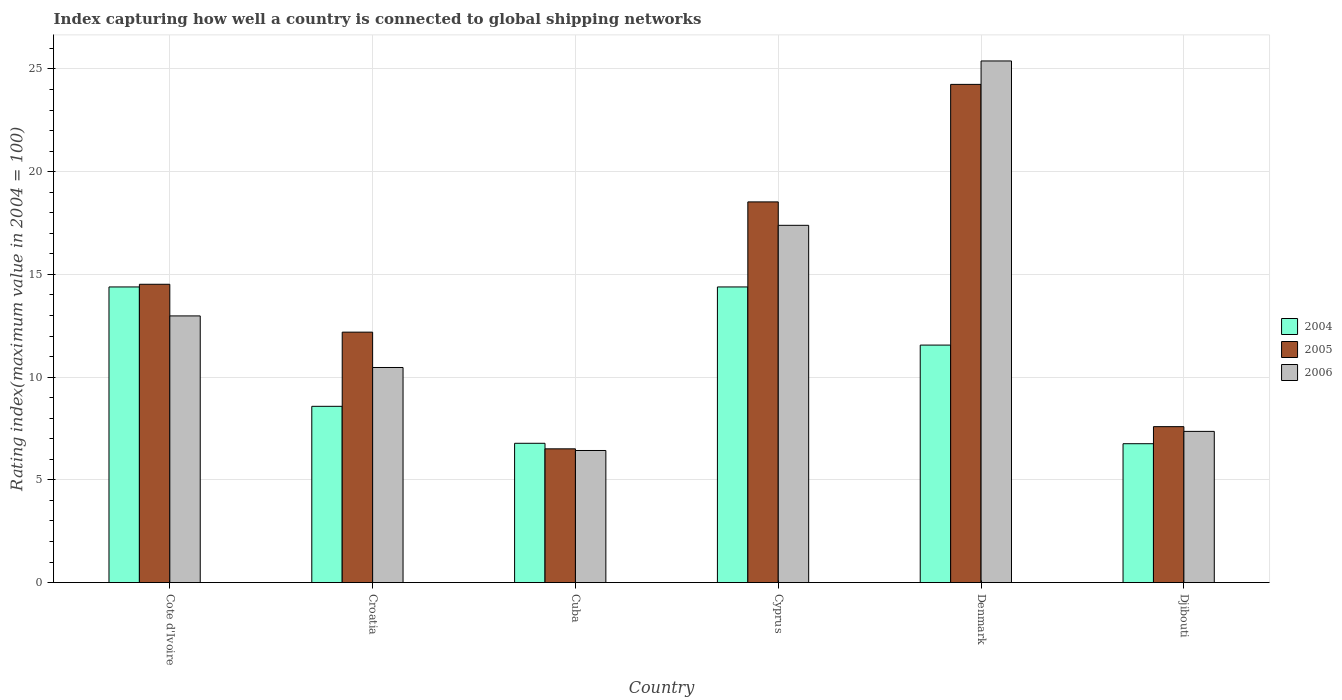How many different coloured bars are there?
Provide a succinct answer. 3. Are the number of bars per tick equal to the number of legend labels?
Provide a succinct answer. Yes. How many bars are there on the 2nd tick from the left?
Give a very brief answer. 3. What is the label of the 1st group of bars from the left?
Keep it short and to the point. Cote d'Ivoire. What is the rating index in 2004 in Denmark?
Provide a short and direct response. 11.56. Across all countries, what is the maximum rating index in 2005?
Provide a short and direct response. 24.25. Across all countries, what is the minimum rating index in 2006?
Make the answer very short. 6.43. In which country was the rating index in 2004 maximum?
Provide a succinct answer. Cote d'Ivoire. In which country was the rating index in 2004 minimum?
Offer a very short reply. Djibouti. What is the total rating index in 2006 in the graph?
Ensure brevity in your answer.  80.02. What is the difference between the rating index in 2006 in Denmark and the rating index in 2005 in Croatia?
Make the answer very short. 13.2. What is the average rating index in 2006 per country?
Your answer should be compact. 13.34. What is the difference between the rating index of/in 2005 and rating index of/in 2004 in Croatia?
Provide a short and direct response. 3.61. In how many countries, is the rating index in 2006 greater than 10?
Offer a terse response. 4. What is the ratio of the rating index in 2006 in Cote d'Ivoire to that in Djibouti?
Your answer should be compact. 1.76. Is the rating index in 2004 in Cote d'Ivoire less than that in Cyprus?
Your response must be concise. No. What is the difference between the highest and the second highest rating index in 2006?
Ensure brevity in your answer.  12.41. What is the difference between the highest and the lowest rating index in 2004?
Your answer should be very brief. 7.63. In how many countries, is the rating index in 2005 greater than the average rating index in 2005 taken over all countries?
Your response must be concise. 3. Is the sum of the rating index in 2004 in Cote d'Ivoire and Denmark greater than the maximum rating index in 2005 across all countries?
Provide a short and direct response. Yes. Is it the case that in every country, the sum of the rating index in 2005 and rating index in 2006 is greater than the rating index in 2004?
Keep it short and to the point. Yes. How many countries are there in the graph?
Give a very brief answer. 6. Does the graph contain any zero values?
Offer a terse response. No. Where does the legend appear in the graph?
Your response must be concise. Center right. How many legend labels are there?
Keep it short and to the point. 3. What is the title of the graph?
Your answer should be very brief. Index capturing how well a country is connected to global shipping networks. Does "1967" appear as one of the legend labels in the graph?
Keep it short and to the point. No. What is the label or title of the Y-axis?
Offer a terse response. Rating index(maximum value in 2004 = 100). What is the Rating index(maximum value in 2004 = 100) in 2004 in Cote d'Ivoire?
Give a very brief answer. 14.39. What is the Rating index(maximum value in 2004 = 100) in 2005 in Cote d'Ivoire?
Provide a succinct answer. 14.52. What is the Rating index(maximum value in 2004 = 100) of 2006 in Cote d'Ivoire?
Offer a very short reply. 12.98. What is the Rating index(maximum value in 2004 = 100) in 2004 in Croatia?
Your answer should be compact. 8.58. What is the Rating index(maximum value in 2004 = 100) of 2005 in Croatia?
Provide a short and direct response. 12.19. What is the Rating index(maximum value in 2004 = 100) of 2006 in Croatia?
Your response must be concise. 10.47. What is the Rating index(maximum value in 2004 = 100) of 2004 in Cuba?
Provide a short and direct response. 6.78. What is the Rating index(maximum value in 2004 = 100) in 2005 in Cuba?
Ensure brevity in your answer.  6.51. What is the Rating index(maximum value in 2004 = 100) of 2006 in Cuba?
Your answer should be compact. 6.43. What is the Rating index(maximum value in 2004 = 100) of 2004 in Cyprus?
Make the answer very short. 14.39. What is the Rating index(maximum value in 2004 = 100) of 2005 in Cyprus?
Offer a very short reply. 18.53. What is the Rating index(maximum value in 2004 = 100) in 2006 in Cyprus?
Ensure brevity in your answer.  17.39. What is the Rating index(maximum value in 2004 = 100) of 2004 in Denmark?
Give a very brief answer. 11.56. What is the Rating index(maximum value in 2004 = 100) in 2005 in Denmark?
Provide a short and direct response. 24.25. What is the Rating index(maximum value in 2004 = 100) of 2006 in Denmark?
Your answer should be very brief. 25.39. What is the Rating index(maximum value in 2004 = 100) in 2004 in Djibouti?
Ensure brevity in your answer.  6.76. What is the Rating index(maximum value in 2004 = 100) of 2005 in Djibouti?
Provide a short and direct response. 7.59. What is the Rating index(maximum value in 2004 = 100) of 2006 in Djibouti?
Offer a very short reply. 7.36. Across all countries, what is the maximum Rating index(maximum value in 2004 = 100) of 2004?
Provide a succinct answer. 14.39. Across all countries, what is the maximum Rating index(maximum value in 2004 = 100) in 2005?
Make the answer very short. 24.25. Across all countries, what is the maximum Rating index(maximum value in 2004 = 100) in 2006?
Keep it short and to the point. 25.39. Across all countries, what is the minimum Rating index(maximum value in 2004 = 100) in 2004?
Provide a succinct answer. 6.76. Across all countries, what is the minimum Rating index(maximum value in 2004 = 100) of 2005?
Provide a succinct answer. 6.51. Across all countries, what is the minimum Rating index(maximum value in 2004 = 100) in 2006?
Give a very brief answer. 6.43. What is the total Rating index(maximum value in 2004 = 100) in 2004 in the graph?
Keep it short and to the point. 62.46. What is the total Rating index(maximum value in 2004 = 100) of 2005 in the graph?
Your answer should be compact. 83.59. What is the total Rating index(maximum value in 2004 = 100) of 2006 in the graph?
Your answer should be very brief. 80.02. What is the difference between the Rating index(maximum value in 2004 = 100) of 2004 in Cote d'Ivoire and that in Croatia?
Offer a very short reply. 5.81. What is the difference between the Rating index(maximum value in 2004 = 100) in 2005 in Cote d'Ivoire and that in Croatia?
Provide a short and direct response. 2.33. What is the difference between the Rating index(maximum value in 2004 = 100) in 2006 in Cote d'Ivoire and that in Croatia?
Your response must be concise. 2.51. What is the difference between the Rating index(maximum value in 2004 = 100) of 2004 in Cote d'Ivoire and that in Cuba?
Ensure brevity in your answer.  7.61. What is the difference between the Rating index(maximum value in 2004 = 100) in 2005 in Cote d'Ivoire and that in Cuba?
Your response must be concise. 8.01. What is the difference between the Rating index(maximum value in 2004 = 100) of 2006 in Cote d'Ivoire and that in Cuba?
Provide a succinct answer. 6.55. What is the difference between the Rating index(maximum value in 2004 = 100) of 2005 in Cote d'Ivoire and that in Cyprus?
Your response must be concise. -4.01. What is the difference between the Rating index(maximum value in 2004 = 100) in 2006 in Cote d'Ivoire and that in Cyprus?
Offer a terse response. -4.41. What is the difference between the Rating index(maximum value in 2004 = 100) in 2004 in Cote d'Ivoire and that in Denmark?
Your answer should be very brief. 2.83. What is the difference between the Rating index(maximum value in 2004 = 100) in 2005 in Cote d'Ivoire and that in Denmark?
Offer a very short reply. -9.73. What is the difference between the Rating index(maximum value in 2004 = 100) in 2006 in Cote d'Ivoire and that in Denmark?
Provide a succinct answer. -12.41. What is the difference between the Rating index(maximum value in 2004 = 100) of 2004 in Cote d'Ivoire and that in Djibouti?
Keep it short and to the point. 7.63. What is the difference between the Rating index(maximum value in 2004 = 100) of 2005 in Cote d'Ivoire and that in Djibouti?
Provide a succinct answer. 6.93. What is the difference between the Rating index(maximum value in 2004 = 100) of 2006 in Cote d'Ivoire and that in Djibouti?
Your answer should be compact. 5.62. What is the difference between the Rating index(maximum value in 2004 = 100) of 2004 in Croatia and that in Cuba?
Offer a terse response. 1.8. What is the difference between the Rating index(maximum value in 2004 = 100) in 2005 in Croatia and that in Cuba?
Keep it short and to the point. 5.68. What is the difference between the Rating index(maximum value in 2004 = 100) in 2006 in Croatia and that in Cuba?
Ensure brevity in your answer.  4.04. What is the difference between the Rating index(maximum value in 2004 = 100) of 2004 in Croatia and that in Cyprus?
Make the answer very short. -5.81. What is the difference between the Rating index(maximum value in 2004 = 100) in 2005 in Croatia and that in Cyprus?
Provide a succinct answer. -6.34. What is the difference between the Rating index(maximum value in 2004 = 100) of 2006 in Croatia and that in Cyprus?
Your answer should be very brief. -6.92. What is the difference between the Rating index(maximum value in 2004 = 100) in 2004 in Croatia and that in Denmark?
Your response must be concise. -2.98. What is the difference between the Rating index(maximum value in 2004 = 100) in 2005 in Croatia and that in Denmark?
Offer a very short reply. -12.06. What is the difference between the Rating index(maximum value in 2004 = 100) in 2006 in Croatia and that in Denmark?
Ensure brevity in your answer.  -14.92. What is the difference between the Rating index(maximum value in 2004 = 100) in 2004 in Croatia and that in Djibouti?
Give a very brief answer. 1.82. What is the difference between the Rating index(maximum value in 2004 = 100) in 2006 in Croatia and that in Djibouti?
Your answer should be compact. 3.11. What is the difference between the Rating index(maximum value in 2004 = 100) of 2004 in Cuba and that in Cyprus?
Ensure brevity in your answer.  -7.61. What is the difference between the Rating index(maximum value in 2004 = 100) of 2005 in Cuba and that in Cyprus?
Offer a very short reply. -12.02. What is the difference between the Rating index(maximum value in 2004 = 100) in 2006 in Cuba and that in Cyprus?
Give a very brief answer. -10.96. What is the difference between the Rating index(maximum value in 2004 = 100) of 2004 in Cuba and that in Denmark?
Give a very brief answer. -4.78. What is the difference between the Rating index(maximum value in 2004 = 100) of 2005 in Cuba and that in Denmark?
Provide a succinct answer. -17.74. What is the difference between the Rating index(maximum value in 2004 = 100) in 2006 in Cuba and that in Denmark?
Offer a terse response. -18.96. What is the difference between the Rating index(maximum value in 2004 = 100) in 2004 in Cuba and that in Djibouti?
Make the answer very short. 0.02. What is the difference between the Rating index(maximum value in 2004 = 100) in 2005 in Cuba and that in Djibouti?
Provide a short and direct response. -1.08. What is the difference between the Rating index(maximum value in 2004 = 100) in 2006 in Cuba and that in Djibouti?
Provide a short and direct response. -0.93. What is the difference between the Rating index(maximum value in 2004 = 100) in 2004 in Cyprus and that in Denmark?
Keep it short and to the point. 2.83. What is the difference between the Rating index(maximum value in 2004 = 100) in 2005 in Cyprus and that in Denmark?
Your response must be concise. -5.72. What is the difference between the Rating index(maximum value in 2004 = 100) of 2004 in Cyprus and that in Djibouti?
Your response must be concise. 7.63. What is the difference between the Rating index(maximum value in 2004 = 100) in 2005 in Cyprus and that in Djibouti?
Make the answer very short. 10.94. What is the difference between the Rating index(maximum value in 2004 = 100) in 2006 in Cyprus and that in Djibouti?
Your response must be concise. 10.03. What is the difference between the Rating index(maximum value in 2004 = 100) of 2004 in Denmark and that in Djibouti?
Ensure brevity in your answer.  4.8. What is the difference between the Rating index(maximum value in 2004 = 100) of 2005 in Denmark and that in Djibouti?
Offer a terse response. 16.66. What is the difference between the Rating index(maximum value in 2004 = 100) in 2006 in Denmark and that in Djibouti?
Offer a very short reply. 18.03. What is the difference between the Rating index(maximum value in 2004 = 100) of 2004 in Cote d'Ivoire and the Rating index(maximum value in 2004 = 100) of 2005 in Croatia?
Your response must be concise. 2.2. What is the difference between the Rating index(maximum value in 2004 = 100) in 2004 in Cote d'Ivoire and the Rating index(maximum value in 2004 = 100) in 2006 in Croatia?
Keep it short and to the point. 3.92. What is the difference between the Rating index(maximum value in 2004 = 100) of 2005 in Cote d'Ivoire and the Rating index(maximum value in 2004 = 100) of 2006 in Croatia?
Your answer should be compact. 4.05. What is the difference between the Rating index(maximum value in 2004 = 100) in 2004 in Cote d'Ivoire and the Rating index(maximum value in 2004 = 100) in 2005 in Cuba?
Make the answer very short. 7.88. What is the difference between the Rating index(maximum value in 2004 = 100) in 2004 in Cote d'Ivoire and the Rating index(maximum value in 2004 = 100) in 2006 in Cuba?
Your answer should be very brief. 7.96. What is the difference between the Rating index(maximum value in 2004 = 100) of 2005 in Cote d'Ivoire and the Rating index(maximum value in 2004 = 100) of 2006 in Cuba?
Make the answer very short. 8.09. What is the difference between the Rating index(maximum value in 2004 = 100) of 2004 in Cote d'Ivoire and the Rating index(maximum value in 2004 = 100) of 2005 in Cyprus?
Ensure brevity in your answer.  -4.14. What is the difference between the Rating index(maximum value in 2004 = 100) in 2005 in Cote d'Ivoire and the Rating index(maximum value in 2004 = 100) in 2006 in Cyprus?
Provide a succinct answer. -2.87. What is the difference between the Rating index(maximum value in 2004 = 100) of 2004 in Cote d'Ivoire and the Rating index(maximum value in 2004 = 100) of 2005 in Denmark?
Provide a succinct answer. -9.86. What is the difference between the Rating index(maximum value in 2004 = 100) of 2004 in Cote d'Ivoire and the Rating index(maximum value in 2004 = 100) of 2006 in Denmark?
Offer a very short reply. -11. What is the difference between the Rating index(maximum value in 2004 = 100) in 2005 in Cote d'Ivoire and the Rating index(maximum value in 2004 = 100) in 2006 in Denmark?
Ensure brevity in your answer.  -10.87. What is the difference between the Rating index(maximum value in 2004 = 100) of 2004 in Cote d'Ivoire and the Rating index(maximum value in 2004 = 100) of 2006 in Djibouti?
Offer a terse response. 7.03. What is the difference between the Rating index(maximum value in 2004 = 100) of 2005 in Cote d'Ivoire and the Rating index(maximum value in 2004 = 100) of 2006 in Djibouti?
Your response must be concise. 7.16. What is the difference between the Rating index(maximum value in 2004 = 100) of 2004 in Croatia and the Rating index(maximum value in 2004 = 100) of 2005 in Cuba?
Provide a succinct answer. 2.07. What is the difference between the Rating index(maximum value in 2004 = 100) in 2004 in Croatia and the Rating index(maximum value in 2004 = 100) in 2006 in Cuba?
Keep it short and to the point. 2.15. What is the difference between the Rating index(maximum value in 2004 = 100) in 2005 in Croatia and the Rating index(maximum value in 2004 = 100) in 2006 in Cuba?
Keep it short and to the point. 5.76. What is the difference between the Rating index(maximum value in 2004 = 100) of 2004 in Croatia and the Rating index(maximum value in 2004 = 100) of 2005 in Cyprus?
Make the answer very short. -9.95. What is the difference between the Rating index(maximum value in 2004 = 100) in 2004 in Croatia and the Rating index(maximum value in 2004 = 100) in 2006 in Cyprus?
Give a very brief answer. -8.81. What is the difference between the Rating index(maximum value in 2004 = 100) in 2005 in Croatia and the Rating index(maximum value in 2004 = 100) in 2006 in Cyprus?
Your answer should be compact. -5.2. What is the difference between the Rating index(maximum value in 2004 = 100) in 2004 in Croatia and the Rating index(maximum value in 2004 = 100) in 2005 in Denmark?
Your answer should be very brief. -15.67. What is the difference between the Rating index(maximum value in 2004 = 100) in 2004 in Croatia and the Rating index(maximum value in 2004 = 100) in 2006 in Denmark?
Provide a succinct answer. -16.81. What is the difference between the Rating index(maximum value in 2004 = 100) in 2005 in Croatia and the Rating index(maximum value in 2004 = 100) in 2006 in Denmark?
Ensure brevity in your answer.  -13.2. What is the difference between the Rating index(maximum value in 2004 = 100) in 2004 in Croatia and the Rating index(maximum value in 2004 = 100) in 2005 in Djibouti?
Keep it short and to the point. 0.99. What is the difference between the Rating index(maximum value in 2004 = 100) of 2004 in Croatia and the Rating index(maximum value in 2004 = 100) of 2006 in Djibouti?
Provide a short and direct response. 1.22. What is the difference between the Rating index(maximum value in 2004 = 100) of 2005 in Croatia and the Rating index(maximum value in 2004 = 100) of 2006 in Djibouti?
Provide a short and direct response. 4.83. What is the difference between the Rating index(maximum value in 2004 = 100) in 2004 in Cuba and the Rating index(maximum value in 2004 = 100) in 2005 in Cyprus?
Offer a very short reply. -11.75. What is the difference between the Rating index(maximum value in 2004 = 100) in 2004 in Cuba and the Rating index(maximum value in 2004 = 100) in 2006 in Cyprus?
Offer a very short reply. -10.61. What is the difference between the Rating index(maximum value in 2004 = 100) of 2005 in Cuba and the Rating index(maximum value in 2004 = 100) of 2006 in Cyprus?
Ensure brevity in your answer.  -10.88. What is the difference between the Rating index(maximum value in 2004 = 100) in 2004 in Cuba and the Rating index(maximum value in 2004 = 100) in 2005 in Denmark?
Your answer should be very brief. -17.47. What is the difference between the Rating index(maximum value in 2004 = 100) in 2004 in Cuba and the Rating index(maximum value in 2004 = 100) in 2006 in Denmark?
Give a very brief answer. -18.61. What is the difference between the Rating index(maximum value in 2004 = 100) of 2005 in Cuba and the Rating index(maximum value in 2004 = 100) of 2006 in Denmark?
Provide a succinct answer. -18.88. What is the difference between the Rating index(maximum value in 2004 = 100) in 2004 in Cuba and the Rating index(maximum value in 2004 = 100) in 2005 in Djibouti?
Offer a terse response. -0.81. What is the difference between the Rating index(maximum value in 2004 = 100) of 2004 in Cuba and the Rating index(maximum value in 2004 = 100) of 2006 in Djibouti?
Ensure brevity in your answer.  -0.58. What is the difference between the Rating index(maximum value in 2004 = 100) in 2005 in Cuba and the Rating index(maximum value in 2004 = 100) in 2006 in Djibouti?
Offer a terse response. -0.85. What is the difference between the Rating index(maximum value in 2004 = 100) of 2004 in Cyprus and the Rating index(maximum value in 2004 = 100) of 2005 in Denmark?
Provide a short and direct response. -9.86. What is the difference between the Rating index(maximum value in 2004 = 100) in 2004 in Cyprus and the Rating index(maximum value in 2004 = 100) in 2006 in Denmark?
Provide a succinct answer. -11. What is the difference between the Rating index(maximum value in 2004 = 100) in 2005 in Cyprus and the Rating index(maximum value in 2004 = 100) in 2006 in Denmark?
Ensure brevity in your answer.  -6.86. What is the difference between the Rating index(maximum value in 2004 = 100) in 2004 in Cyprus and the Rating index(maximum value in 2004 = 100) in 2005 in Djibouti?
Your response must be concise. 6.8. What is the difference between the Rating index(maximum value in 2004 = 100) of 2004 in Cyprus and the Rating index(maximum value in 2004 = 100) of 2006 in Djibouti?
Your response must be concise. 7.03. What is the difference between the Rating index(maximum value in 2004 = 100) in 2005 in Cyprus and the Rating index(maximum value in 2004 = 100) in 2006 in Djibouti?
Your answer should be very brief. 11.17. What is the difference between the Rating index(maximum value in 2004 = 100) in 2004 in Denmark and the Rating index(maximum value in 2004 = 100) in 2005 in Djibouti?
Provide a short and direct response. 3.97. What is the difference between the Rating index(maximum value in 2004 = 100) of 2004 in Denmark and the Rating index(maximum value in 2004 = 100) of 2006 in Djibouti?
Provide a succinct answer. 4.2. What is the difference between the Rating index(maximum value in 2004 = 100) of 2005 in Denmark and the Rating index(maximum value in 2004 = 100) of 2006 in Djibouti?
Make the answer very short. 16.89. What is the average Rating index(maximum value in 2004 = 100) of 2004 per country?
Make the answer very short. 10.41. What is the average Rating index(maximum value in 2004 = 100) of 2005 per country?
Provide a short and direct response. 13.93. What is the average Rating index(maximum value in 2004 = 100) of 2006 per country?
Provide a succinct answer. 13.34. What is the difference between the Rating index(maximum value in 2004 = 100) in 2004 and Rating index(maximum value in 2004 = 100) in 2005 in Cote d'Ivoire?
Your answer should be very brief. -0.13. What is the difference between the Rating index(maximum value in 2004 = 100) of 2004 and Rating index(maximum value in 2004 = 100) of 2006 in Cote d'Ivoire?
Ensure brevity in your answer.  1.41. What is the difference between the Rating index(maximum value in 2004 = 100) in 2005 and Rating index(maximum value in 2004 = 100) in 2006 in Cote d'Ivoire?
Provide a short and direct response. 1.54. What is the difference between the Rating index(maximum value in 2004 = 100) of 2004 and Rating index(maximum value in 2004 = 100) of 2005 in Croatia?
Your response must be concise. -3.61. What is the difference between the Rating index(maximum value in 2004 = 100) in 2004 and Rating index(maximum value in 2004 = 100) in 2006 in Croatia?
Make the answer very short. -1.89. What is the difference between the Rating index(maximum value in 2004 = 100) in 2005 and Rating index(maximum value in 2004 = 100) in 2006 in Croatia?
Provide a short and direct response. 1.72. What is the difference between the Rating index(maximum value in 2004 = 100) in 2004 and Rating index(maximum value in 2004 = 100) in 2005 in Cuba?
Give a very brief answer. 0.27. What is the difference between the Rating index(maximum value in 2004 = 100) in 2004 and Rating index(maximum value in 2004 = 100) in 2006 in Cuba?
Provide a succinct answer. 0.35. What is the difference between the Rating index(maximum value in 2004 = 100) of 2004 and Rating index(maximum value in 2004 = 100) of 2005 in Cyprus?
Your answer should be very brief. -4.14. What is the difference between the Rating index(maximum value in 2004 = 100) in 2004 and Rating index(maximum value in 2004 = 100) in 2006 in Cyprus?
Your response must be concise. -3. What is the difference between the Rating index(maximum value in 2004 = 100) of 2005 and Rating index(maximum value in 2004 = 100) of 2006 in Cyprus?
Your answer should be very brief. 1.14. What is the difference between the Rating index(maximum value in 2004 = 100) in 2004 and Rating index(maximum value in 2004 = 100) in 2005 in Denmark?
Make the answer very short. -12.69. What is the difference between the Rating index(maximum value in 2004 = 100) of 2004 and Rating index(maximum value in 2004 = 100) of 2006 in Denmark?
Make the answer very short. -13.83. What is the difference between the Rating index(maximum value in 2004 = 100) in 2005 and Rating index(maximum value in 2004 = 100) in 2006 in Denmark?
Your answer should be very brief. -1.14. What is the difference between the Rating index(maximum value in 2004 = 100) in 2004 and Rating index(maximum value in 2004 = 100) in 2005 in Djibouti?
Ensure brevity in your answer.  -0.83. What is the difference between the Rating index(maximum value in 2004 = 100) of 2005 and Rating index(maximum value in 2004 = 100) of 2006 in Djibouti?
Make the answer very short. 0.23. What is the ratio of the Rating index(maximum value in 2004 = 100) of 2004 in Cote d'Ivoire to that in Croatia?
Keep it short and to the point. 1.68. What is the ratio of the Rating index(maximum value in 2004 = 100) of 2005 in Cote d'Ivoire to that in Croatia?
Keep it short and to the point. 1.19. What is the ratio of the Rating index(maximum value in 2004 = 100) in 2006 in Cote d'Ivoire to that in Croatia?
Give a very brief answer. 1.24. What is the ratio of the Rating index(maximum value in 2004 = 100) of 2004 in Cote d'Ivoire to that in Cuba?
Give a very brief answer. 2.12. What is the ratio of the Rating index(maximum value in 2004 = 100) in 2005 in Cote d'Ivoire to that in Cuba?
Your answer should be compact. 2.23. What is the ratio of the Rating index(maximum value in 2004 = 100) in 2006 in Cote d'Ivoire to that in Cuba?
Provide a succinct answer. 2.02. What is the ratio of the Rating index(maximum value in 2004 = 100) of 2004 in Cote d'Ivoire to that in Cyprus?
Keep it short and to the point. 1. What is the ratio of the Rating index(maximum value in 2004 = 100) of 2005 in Cote d'Ivoire to that in Cyprus?
Your response must be concise. 0.78. What is the ratio of the Rating index(maximum value in 2004 = 100) of 2006 in Cote d'Ivoire to that in Cyprus?
Your answer should be very brief. 0.75. What is the ratio of the Rating index(maximum value in 2004 = 100) of 2004 in Cote d'Ivoire to that in Denmark?
Make the answer very short. 1.24. What is the ratio of the Rating index(maximum value in 2004 = 100) of 2005 in Cote d'Ivoire to that in Denmark?
Keep it short and to the point. 0.6. What is the ratio of the Rating index(maximum value in 2004 = 100) of 2006 in Cote d'Ivoire to that in Denmark?
Make the answer very short. 0.51. What is the ratio of the Rating index(maximum value in 2004 = 100) in 2004 in Cote d'Ivoire to that in Djibouti?
Offer a very short reply. 2.13. What is the ratio of the Rating index(maximum value in 2004 = 100) in 2005 in Cote d'Ivoire to that in Djibouti?
Your answer should be compact. 1.91. What is the ratio of the Rating index(maximum value in 2004 = 100) of 2006 in Cote d'Ivoire to that in Djibouti?
Provide a short and direct response. 1.76. What is the ratio of the Rating index(maximum value in 2004 = 100) of 2004 in Croatia to that in Cuba?
Offer a terse response. 1.27. What is the ratio of the Rating index(maximum value in 2004 = 100) of 2005 in Croatia to that in Cuba?
Ensure brevity in your answer.  1.87. What is the ratio of the Rating index(maximum value in 2004 = 100) of 2006 in Croatia to that in Cuba?
Give a very brief answer. 1.63. What is the ratio of the Rating index(maximum value in 2004 = 100) of 2004 in Croatia to that in Cyprus?
Your answer should be very brief. 0.6. What is the ratio of the Rating index(maximum value in 2004 = 100) of 2005 in Croatia to that in Cyprus?
Provide a short and direct response. 0.66. What is the ratio of the Rating index(maximum value in 2004 = 100) of 2006 in Croatia to that in Cyprus?
Offer a very short reply. 0.6. What is the ratio of the Rating index(maximum value in 2004 = 100) of 2004 in Croatia to that in Denmark?
Provide a short and direct response. 0.74. What is the ratio of the Rating index(maximum value in 2004 = 100) in 2005 in Croatia to that in Denmark?
Ensure brevity in your answer.  0.5. What is the ratio of the Rating index(maximum value in 2004 = 100) of 2006 in Croatia to that in Denmark?
Your answer should be compact. 0.41. What is the ratio of the Rating index(maximum value in 2004 = 100) in 2004 in Croatia to that in Djibouti?
Your response must be concise. 1.27. What is the ratio of the Rating index(maximum value in 2004 = 100) of 2005 in Croatia to that in Djibouti?
Ensure brevity in your answer.  1.61. What is the ratio of the Rating index(maximum value in 2004 = 100) in 2006 in Croatia to that in Djibouti?
Offer a very short reply. 1.42. What is the ratio of the Rating index(maximum value in 2004 = 100) of 2004 in Cuba to that in Cyprus?
Ensure brevity in your answer.  0.47. What is the ratio of the Rating index(maximum value in 2004 = 100) of 2005 in Cuba to that in Cyprus?
Make the answer very short. 0.35. What is the ratio of the Rating index(maximum value in 2004 = 100) of 2006 in Cuba to that in Cyprus?
Provide a succinct answer. 0.37. What is the ratio of the Rating index(maximum value in 2004 = 100) in 2004 in Cuba to that in Denmark?
Give a very brief answer. 0.59. What is the ratio of the Rating index(maximum value in 2004 = 100) in 2005 in Cuba to that in Denmark?
Your answer should be compact. 0.27. What is the ratio of the Rating index(maximum value in 2004 = 100) in 2006 in Cuba to that in Denmark?
Offer a very short reply. 0.25. What is the ratio of the Rating index(maximum value in 2004 = 100) of 2005 in Cuba to that in Djibouti?
Ensure brevity in your answer.  0.86. What is the ratio of the Rating index(maximum value in 2004 = 100) in 2006 in Cuba to that in Djibouti?
Make the answer very short. 0.87. What is the ratio of the Rating index(maximum value in 2004 = 100) of 2004 in Cyprus to that in Denmark?
Your answer should be compact. 1.24. What is the ratio of the Rating index(maximum value in 2004 = 100) of 2005 in Cyprus to that in Denmark?
Give a very brief answer. 0.76. What is the ratio of the Rating index(maximum value in 2004 = 100) of 2006 in Cyprus to that in Denmark?
Your answer should be compact. 0.68. What is the ratio of the Rating index(maximum value in 2004 = 100) of 2004 in Cyprus to that in Djibouti?
Offer a terse response. 2.13. What is the ratio of the Rating index(maximum value in 2004 = 100) of 2005 in Cyprus to that in Djibouti?
Your answer should be compact. 2.44. What is the ratio of the Rating index(maximum value in 2004 = 100) in 2006 in Cyprus to that in Djibouti?
Provide a short and direct response. 2.36. What is the ratio of the Rating index(maximum value in 2004 = 100) in 2004 in Denmark to that in Djibouti?
Provide a short and direct response. 1.71. What is the ratio of the Rating index(maximum value in 2004 = 100) of 2005 in Denmark to that in Djibouti?
Make the answer very short. 3.19. What is the ratio of the Rating index(maximum value in 2004 = 100) in 2006 in Denmark to that in Djibouti?
Your answer should be compact. 3.45. What is the difference between the highest and the second highest Rating index(maximum value in 2004 = 100) of 2004?
Offer a terse response. 0. What is the difference between the highest and the second highest Rating index(maximum value in 2004 = 100) of 2005?
Your answer should be very brief. 5.72. What is the difference between the highest and the lowest Rating index(maximum value in 2004 = 100) in 2004?
Provide a succinct answer. 7.63. What is the difference between the highest and the lowest Rating index(maximum value in 2004 = 100) in 2005?
Offer a terse response. 17.74. What is the difference between the highest and the lowest Rating index(maximum value in 2004 = 100) of 2006?
Ensure brevity in your answer.  18.96. 